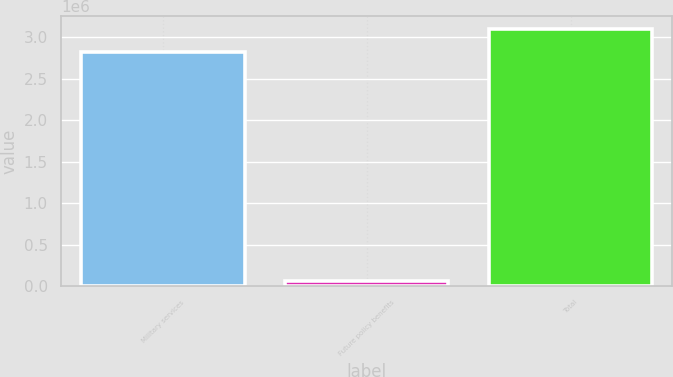Convert chart to OTSL. <chart><loc_0><loc_0><loc_500><loc_500><bar_chart><fcel>Military services<fcel>Future policy benefits<fcel>Total<nl><fcel>2.81979e+06<fcel>64338<fcel>3.10177e+06<nl></chart> 